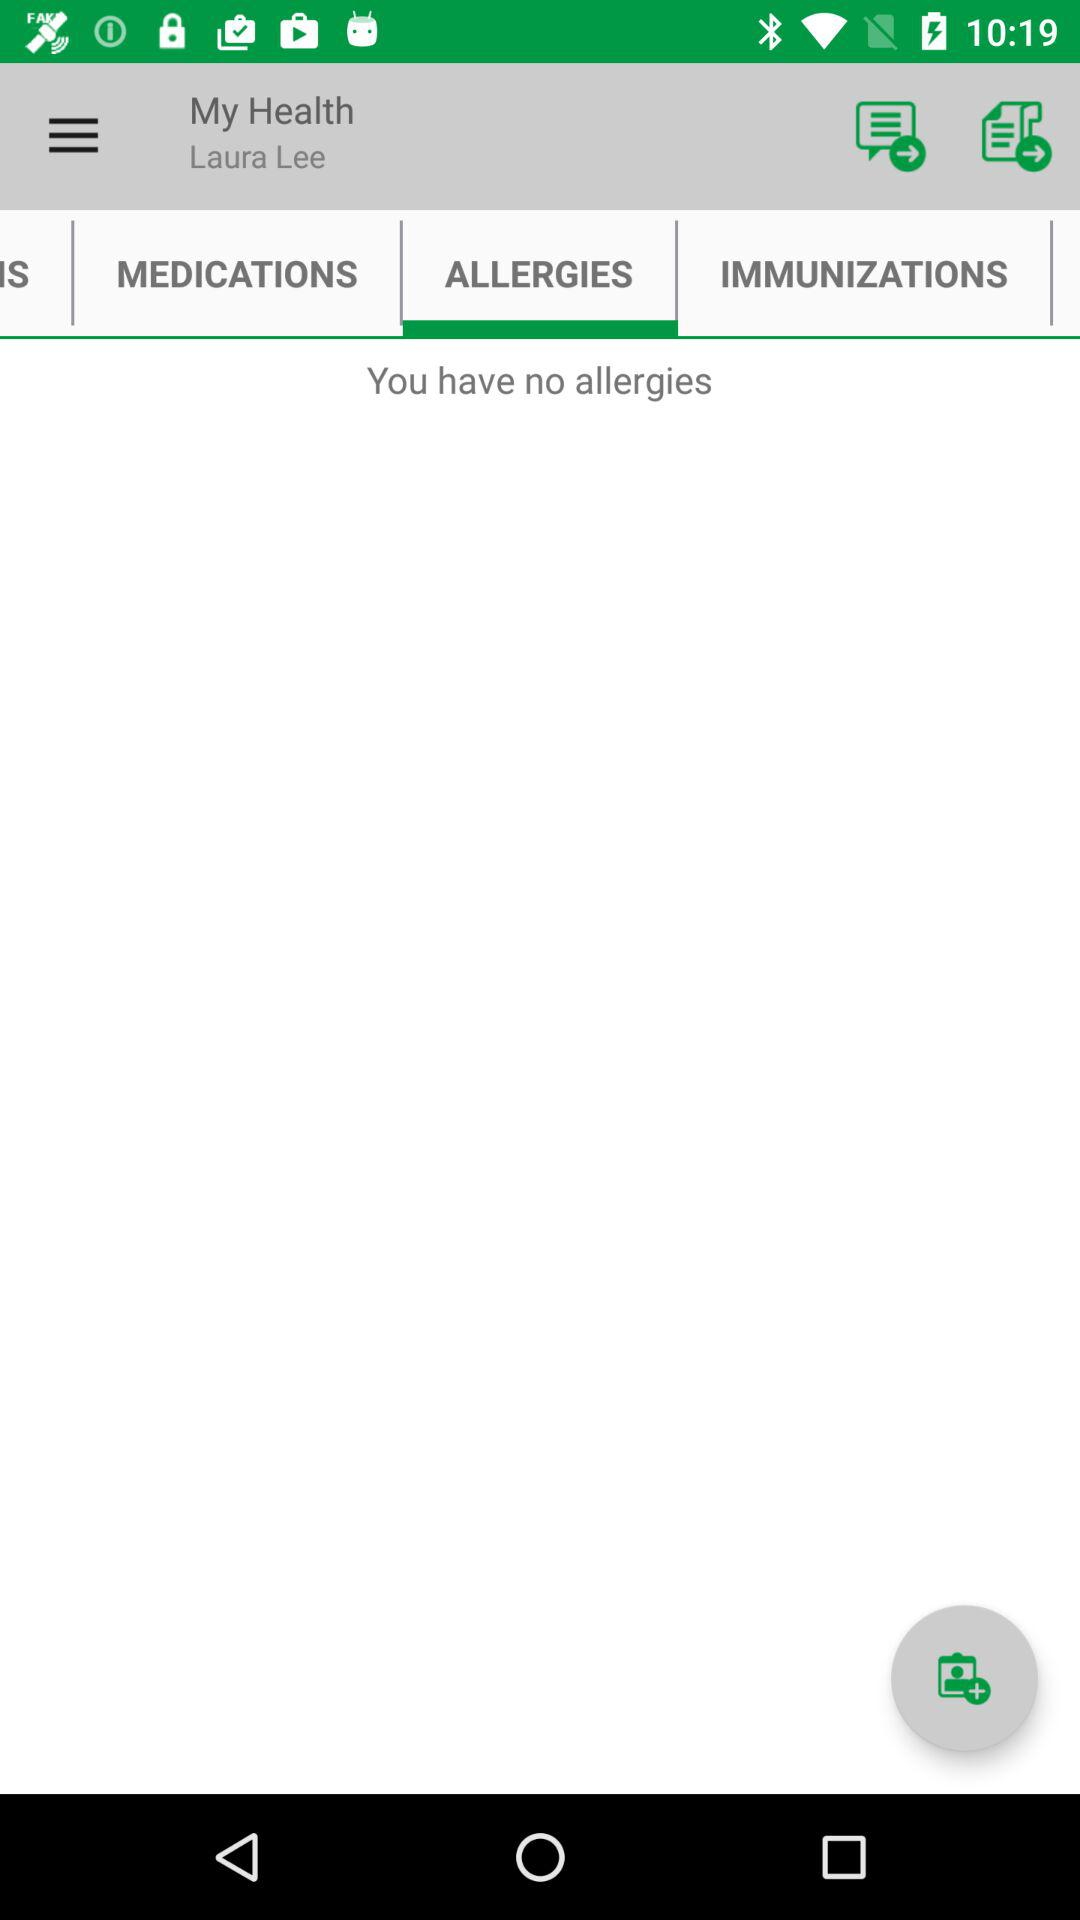Which tab is selected? The selected tab is "ALLERGIES". 